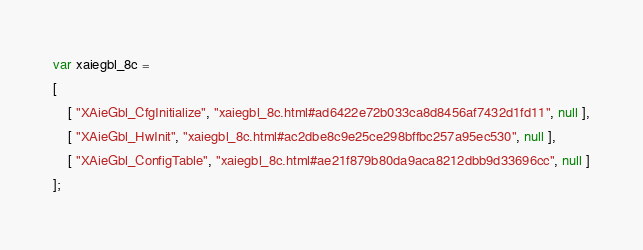<code> <loc_0><loc_0><loc_500><loc_500><_JavaScript_>var xaiegbl_8c =
[
    [ "XAieGbl_CfgInitialize", "xaiegbl_8c.html#ad6422e72b033ca8d8456af7432d1fd11", null ],
    [ "XAieGbl_HwInit", "xaiegbl_8c.html#ac2dbe8c9e25ce298bffbc257a95ec530", null ],
    [ "XAieGbl_ConfigTable", "xaiegbl_8c.html#ae21f879b80da9aca8212dbb9d33696cc", null ]
];</code> 